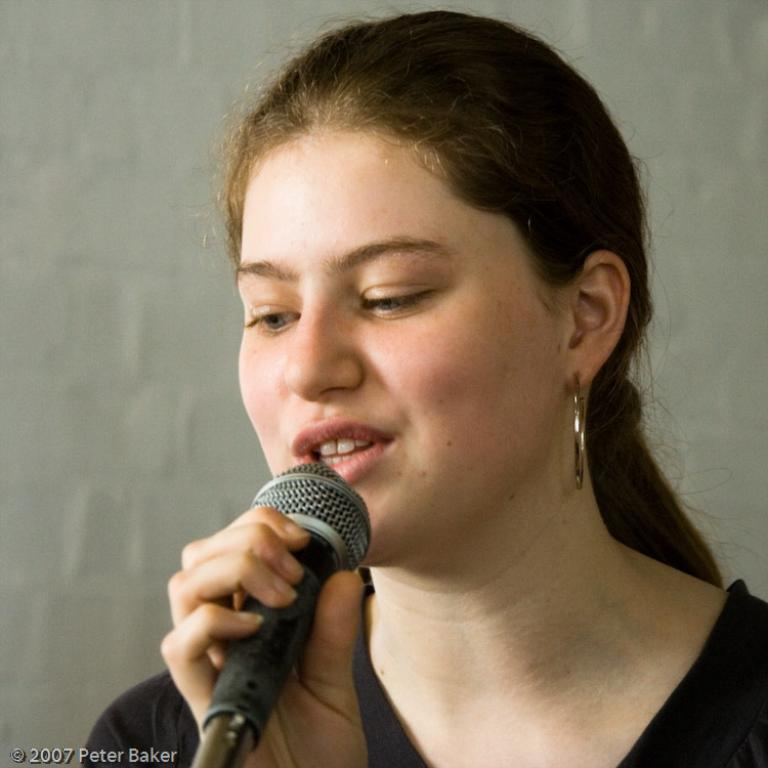Who is the main subject in the image? There is a woman in the image. What is the woman wearing? The woman is wearing a black dress. What object is the woman holding in the image? The woman is holding a phone. What might the woman be doing with the phone? The woman appears to be talking, so she might be using the phone to communicate. What groundbreaking discovery was made on the floor in the image? There is no mention of a groundbreaking discovery or a floor in the image. 